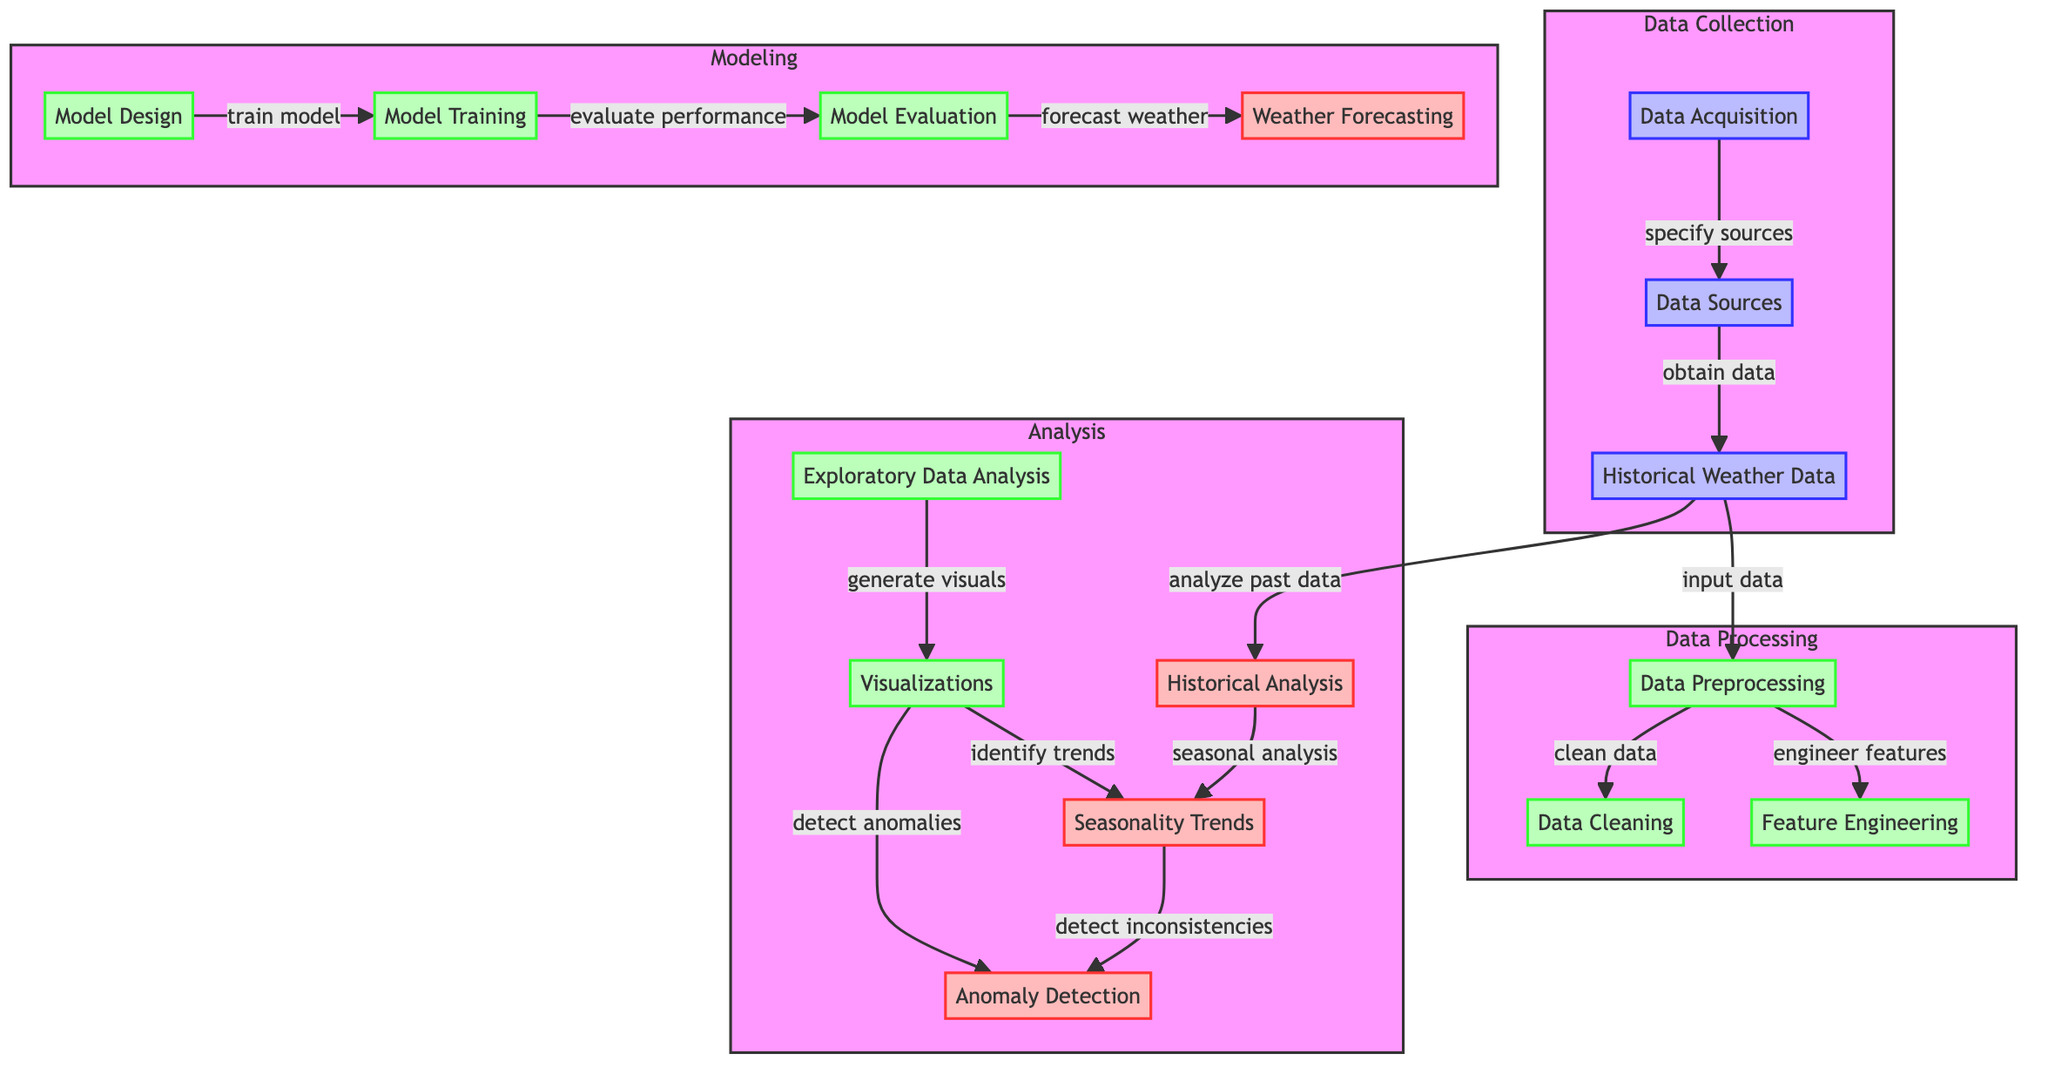What is the first step in the process? The first step is "Data Acquisition" as indicated at the top of the diagram, from which all other processes flow.
Answer: Data Acquisition How many output nodes are there in the diagram? The outputs in the diagram are "Seasonality Trends," "Anomaly Detection," "Historical Analysis," and "Forecasting," totaling four output nodes.
Answer: Four What does the "Historical Weather Data" node lead to? The "Historical Weather Data" node directly leads to "Preprocessing" and "Historical Analysis," indicating its role in both data preparation and historical examination processes.
Answer: Preprocessing, Historical Analysis Which process precedes "Model Training"? "Model Design" must be completed before "Model Training," as it is the initial stage that sets the foundation for training the model.
Answer: Model Design What is the function of the "Anomaly Detection" node? The main function of "Anomaly Detection" is to identify data inconsistencies after analyzing trends, as indicated by its connection to the "Seasonality Trends" node.
Answer: Identify inconsistencies Which nodes are classified under the "Data Processing" subgraph? The "Data Processing" subgraph includes "Preprocessing," "Cleaning," and "Feature Engineering" nodes that signify steps taken to prepare data for analysis.
Answer: Preprocessing, Cleaning, Feature Engineering What information does the "Visualizations" node provide? The "Visualizations" node generates visuals that lead to identifying trends and detecting anomalies, showcasing its dual purpose in exploratory analysis.
Answer: Generate visuals What connects "Seasonality Trends" and "Anomaly Detection"? "Seasonality Trends" leads to "Anomaly Detection," indicating that the trend analysis informs the process of detecting anomalies in the data.
Answer: Connects "Seasonality Trends" to "Anomaly Detection" How does the "Evaluation" process relate to forecasting? The "Evaluation" process leads to "Forecasting," demonstrating how the performance of the trained model directly contributes to making weather forecasts.
Answer: Leads to Forecasting 